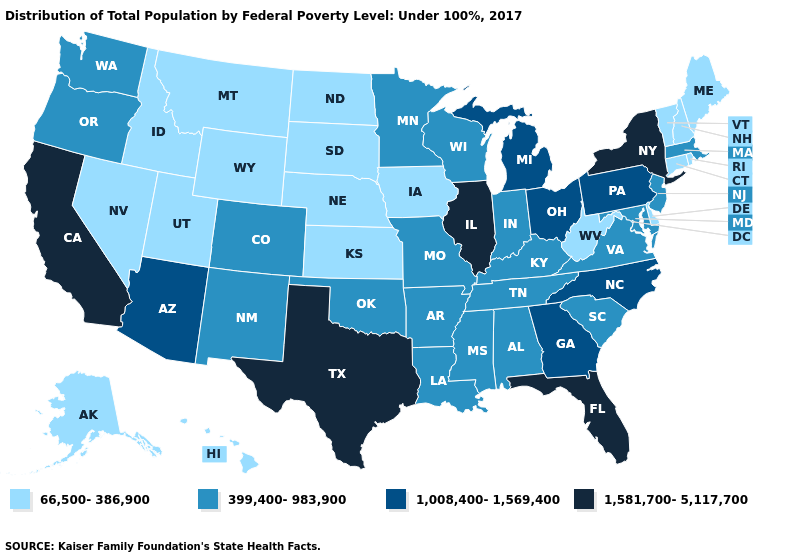How many symbols are there in the legend?
Answer briefly. 4. What is the highest value in states that border Nebraska?
Keep it brief. 399,400-983,900. What is the value of Mississippi?
Keep it brief. 399,400-983,900. Does Colorado have the lowest value in the West?
Give a very brief answer. No. What is the value of Wyoming?
Write a very short answer. 66,500-386,900. Does Ohio have the highest value in the MidWest?
Answer briefly. No. Does Iowa have a lower value than Rhode Island?
Keep it brief. No. Does Illinois have the highest value in the MidWest?
Write a very short answer. Yes. Name the states that have a value in the range 1,581,700-5,117,700?
Write a very short answer. California, Florida, Illinois, New York, Texas. Does the map have missing data?
Answer briefly. No. Among the states that border New York , does New Jersey have the lowest value?
Be succinct. No. Name the states that have a value in the range 1,008,400-1,569,400?
Be succinct. Arizona, Georgia, Michigan, North Carolina, Ohio, Pennsylvania. What is the value of South Dakota?
Concise answer only. 66,500-386,900. Which states have the lowest value in the USA?
Answer briefly. Alaska, Connecticut, Delaware, Hawaii, Idaho, Iowa, Kansas, Maine, Montana, Nebraska, Nevada, New Hampshire, North Dakota, Rhode Island, South Dakota, Utah, Vermont, West Virginia, Wyoming. Does Arkansas have a higher value than Nebraska?
Give a very brief answer. Yes. 